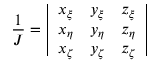Convert formula to latex. <formula><loc_0><loc_0><loc_500><loc_500>\frac { 1 } { J } = \left | \begin{array} { l l l } { x _ { \xi } } & { y _ { \xi } } & { z _ { \xi } } \\ { x _ { \eta } } & { y _ { \eta } } & { z _ { \eta } } \\ { x _ { \zeta } } & { y _ { \zeta } } & { z _ { \zeta } } \end{array} \right |</formula> 